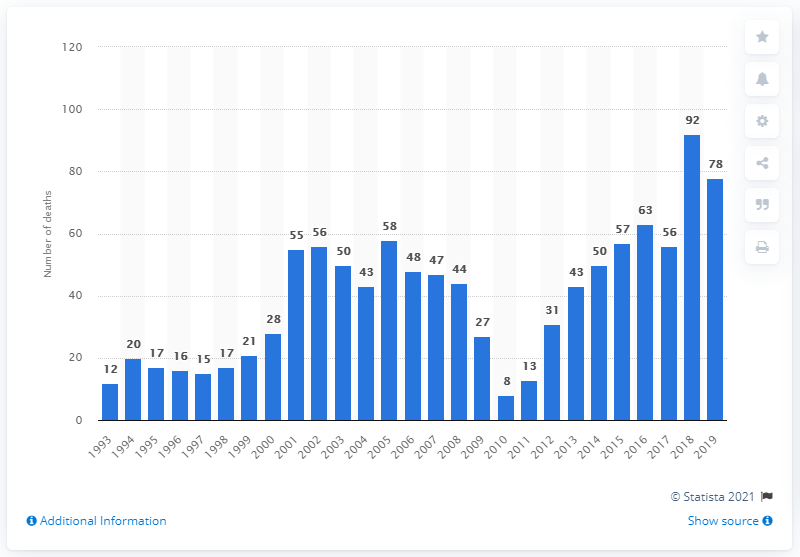Draw attention to some important aspects in this diagram. In 2018, 92 people lost their lives due to the use of MDMA/ecstasy in England and Wales. In 2018, 92 people died as a result of MDMA/ecstasy use in England and Wales. In 2019, a total of 78 deaths were recorded as a result of MDMA use. 